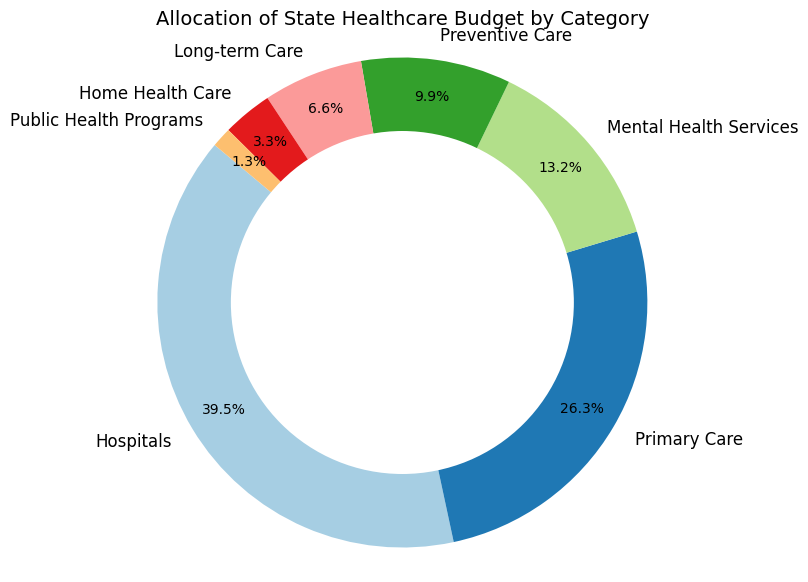what category receives the highest portion of the budget? The pie chart shows the percentage allocation of the healthcare budget across different categories. By looking at the portion sizes, the segment labeled "Hospitals" occupies the largest area.
Answer: Hospitals what is the combined budget allocation for Preventive Care and Long-term Care? From the pie chart, Preventive Care is allocated $75,000,000 and Long-term Care is allocated $50,000,000. Adding these amounts gives a combined allocation of $75,000,000 + $50,000,000 = $125,000,000.
Answer: $125,000,000 how does the budget allocation for Primary Care compare to that for Mental Health Services? Looking at the pie chart, Primary Care has a larger portion compared to Mental Health Services. Specifically, Primary Care is allocated $200,000,000 whereas Mental Health Services gets $100,000,000.
Answer: Primary Care has double the allocation of Mental Health Services which category has the smallest allocation, and what is its amount and percentage? The pie chart segment for "Public Health Programs" is the smallest in both size and percentage. Its allocation is shown as $10,000,000, which represents 1.1% of the total budget.
Answer: Public Health Programs, $10,000,000, 1.1% what percentage of the budget is allocated to Mental Health Services? From the pie chart, Mental Health Services takes up a portion labeled with 10.0%.
Answer: 10.0% how does the budget allocation for Hospitals and Primary Care collectively compare to the total budget? Hospitals are allocated $300,000,000 and Primary Care $200,000,000. Collectively, their total is $300,000,000 + $200,000,000 = $500,000,000. Considering the overall budget as the sum of all categories ($760,000,000), the combined percentage is ($500,000,000 / $760,000,000) * 100% = 65.8%.
Answer: 65.8% if we combined the allocations for Home Health Care and Public Health Programs, what percentage of the total budget would that represent? Home Health Care is allocated $25,000,000 and Public Health Programs $10,000,000. Together, they total $25,000,000 + $10,000,000 = $35,000,000. The percentage is then ($35,000,000 / $760,000,000) * 100% = 4.6%.
Answer: 4.6% what visual attribute indicates the budget allocation for Long-term Care as the second smallest? The pie chart uses the relative size of the segments to indicate budget allocations. The "Long-term Care" segment is visually the second smallest after "Public Health Programs."
Answer: Segment size 